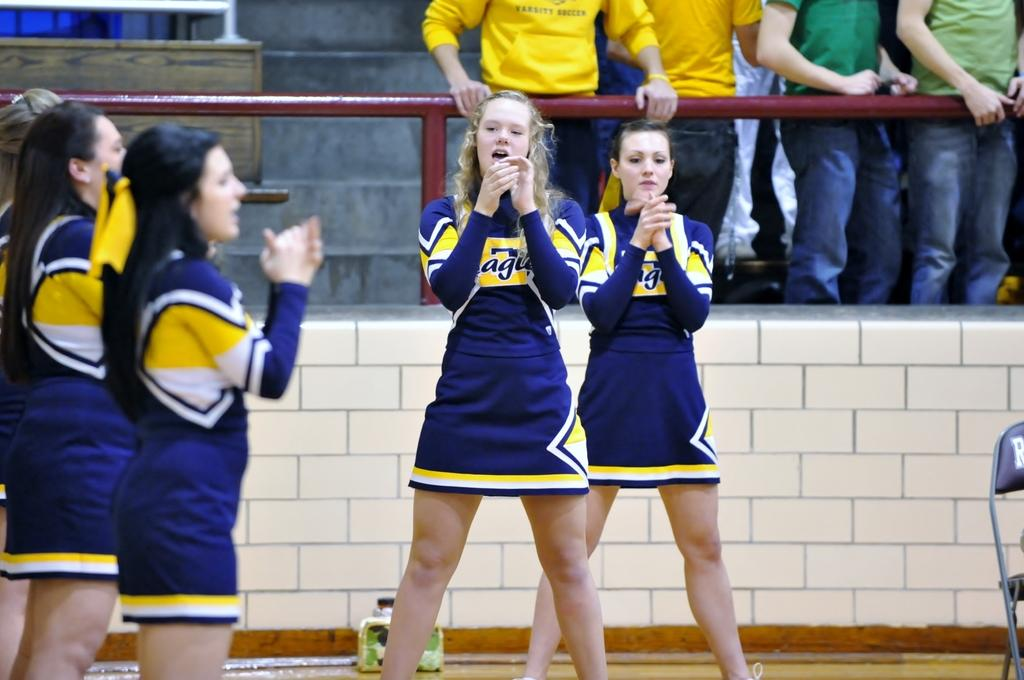<image>
Provide a brief description of the given image. the letters ag are on the shirt of the cheerleader 